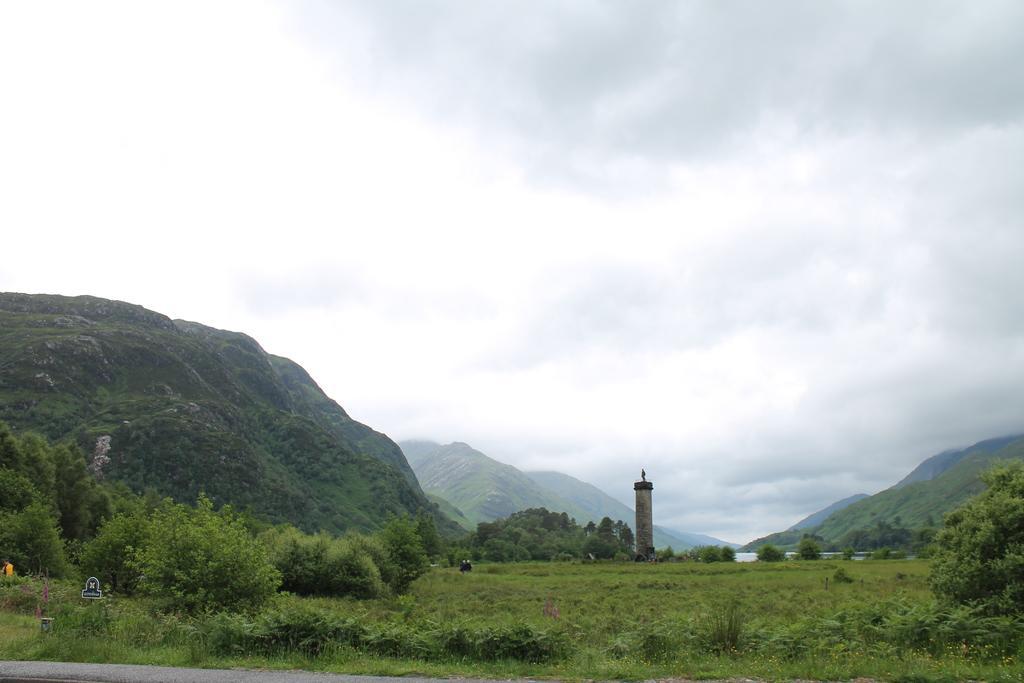Describe this image in one or two sentences. This image consists of mountains. At the bottom, we can see green grass and plants. In the middle, it looks like a lighthouse. At the top, there are clouds in the sky. 